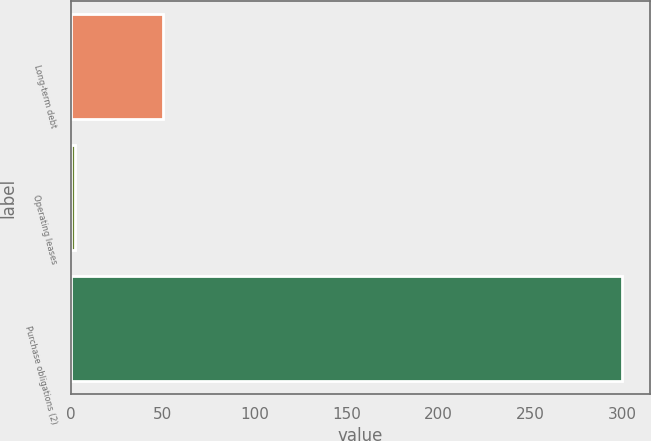Convert chart. <chart><loc_0><loc_0><loc_500><loc_500><bar_chart><fcel>Long-term debt<fcel>Operating leases<fcel>Purchase obligations (2)<nl><fcel>50<fcel>2<fcel>300<nl></chart> 